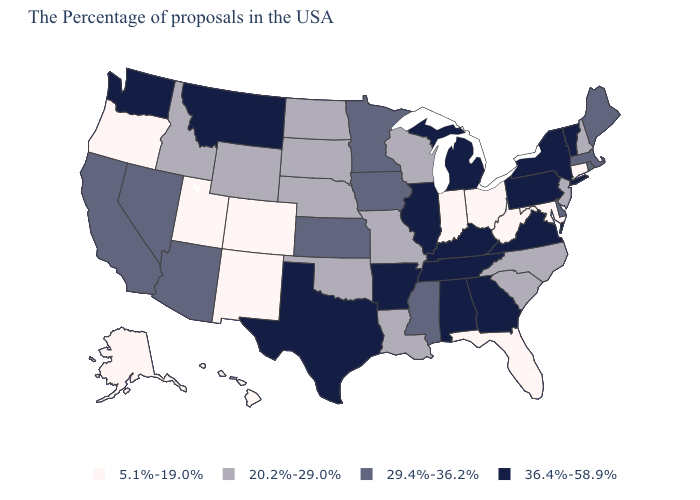Name the states that have a value in the range 36.4%-58.9%?
Concise answer only. Vermont, New York, Pennsylvania, Virginia, Georgia, Michigan, Kentucky, Alabama, Tennessee, Illinois, Arkansas, Texas, Montana, Washington. What is the value of Oklahoma?
Quick response, please. 20.2%-29.0%. What is the value of Virginia?
Answer briefly. 36.4%-58.9%. Name the states that have a value in the range 20.2%-29.0%?
Short answer required. New Hampshire, New Jersey, North Carolina, South Carolina, Wisconsin, Louisiana, Missouri, Nebraska, Oklahoma, South Dakota, North Dakota, Wyoming, Idaho. What is the lowest value in the USA?
Concise answer only. 5.1%-19.0%. Name the states that have a value in the range 5.1%-19.0%?
Write a very short answer. Connecticut, Maryland, West Virginia, Ohio, Florida, Indiana, Colorado, New Mexico, Utah, Oregon, Alaska, Hawaii. What is the value of Maryland?
Give a very brief answer. 5.1%-19.0%. Which states have the lowest value in the USA?
Give a very brief answer. Connecticut, Maryland, West Virginia, Ohio, Florida, Indiana, Colorado, New Mexico, Utah, Oregon, Alaska, Hawaii. What is the highest value in the USA?
Quick response, please. 36.4%-58.9%. How many symbols are there in the legend?
Be succinct. 4. Name the states that have a value in the range 20.2%-29.0%?
Write a very short answer. New Hampshire, New Jersey, North Carolina, South Carolina, Wisconsin, Louisiana, Missouri, Nebraska, Oklahoma, South Dakota, North Dakota, Wyoming, Idaho. Name the states that have a value in the range 5.1%-19.0%?
Quick response, please. Connecticut, Maryland, West Virginia, Ohio, Florida, Indiana, Colorado, New Mexico, Utah, Oregon, Alaska, Hawaii. Among the states that border Massachusetts , does New Hampshire have the lowest value?
Short answer required. No. Which states have the lowest value in the USA?
Short answer required. Connecticut, Maryland, West Virginia, Ohio, Florida, Indiana, Colorado, New Mexico, Utah, Oregon, Alaska, Hawaii. Does the map have missing data?
Keep it brief. No. 